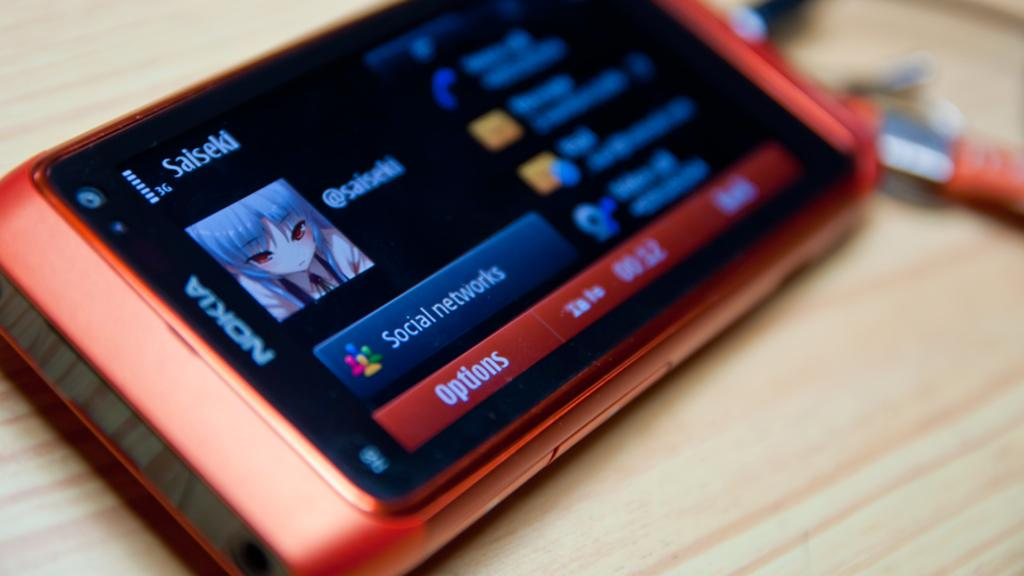Provide a one-sentence caption for the provided image. a nokia phone with the options bar open at the bottom. 